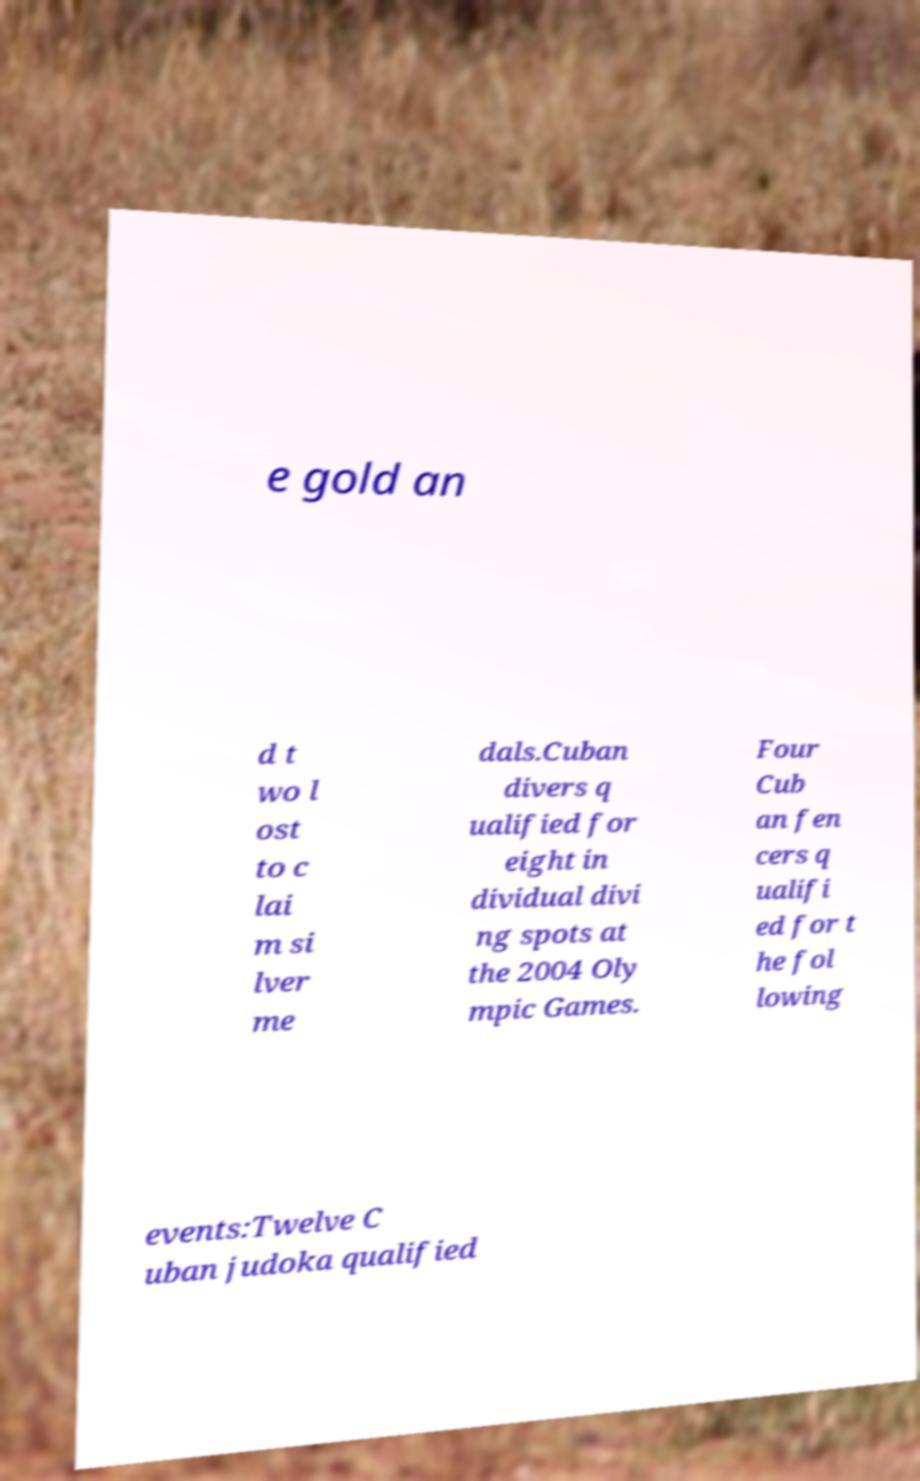I need the written content from this picture converted into text. Can you do that? e gold an d t wo l ost to c lai m si lver me dals.Cuban divers q ualified for eight in dividual divi ng spots at the 2004 Oly mpic Games. Four Cub an fen cers q ualifi ed for t he fol lowing events:Twelve C uban judoka qualified 